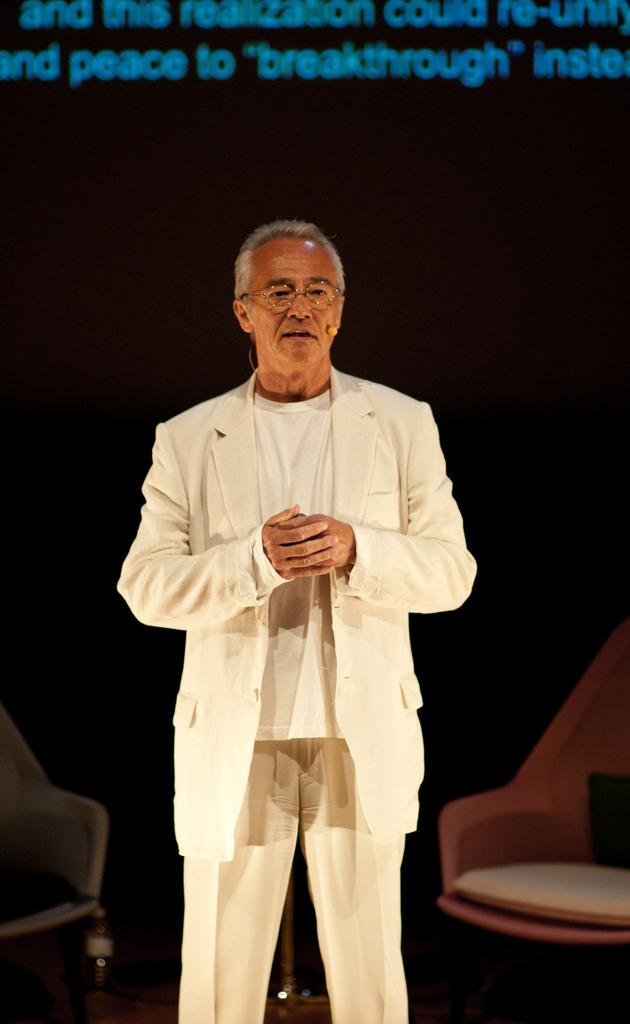What is the main subject of the image? There is a man standing in the image. What can be seen in the background of the image? There are chairs and a text written on a screen in the background of the image. What type of tub is visible in the image? There is no tub present in the image. How many balls are being juggled by the man in the image? The man is not juggling any balls in the image. 